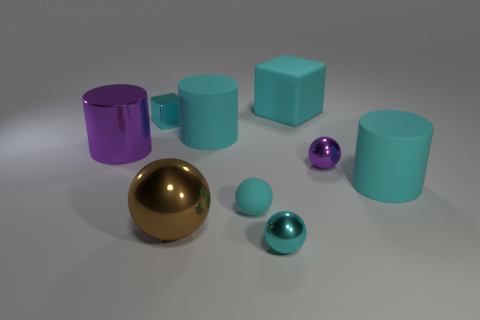Does the cyan metallic sphere have the same size as the brown ball?
Keep it short and to the point. No. Does the rubber block have the same color as the small block?
Your answer should be very brief. Yes. The rubber sphere that is the same size as the cyan metallic ball is what color?
Provide a short and direct response. Cyan. What size is the purple object right of the tiny shiny cube?
Your response must be concise. Small. There is a tiny thing that is in front of the brown thing; is there a big shiny sphere left of it?
Offer a terse response. Yes. Do the cyan cylinder left of the cyan shiny ball and the large block have the same material?
Offer a terse response. Yes. What number of tiny things are both in front of the large purple cylinder and behind the large metallic ball?
Your answer should be compact. 2. What number of cyan cubes are the same material as the tiny purple ball?
Offer a very short reply. 1. What is the color of the ball that is the same material as the large cyan cube?
Your response must be concise. Cyan. Is the number of things less than the number of small purple metal spheres?
Give a very brief answer. No. 